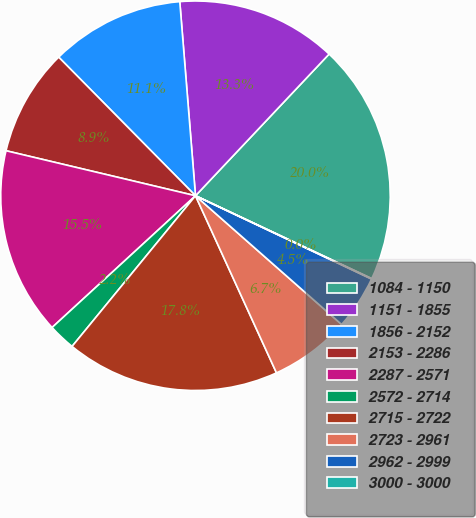<chart> <loc_0><loc_0><loc_500><loc_500><pie_chart><fcel>1084 - 1150<fcel>1151 - 1855<fcel>1856 - 2152<fcel>2153 - 2286<fcel>2287 - 2571<fcel>2572 - 2714<fcel>2715 - 2722<fcel>2723 - 2961<fcel>2962 - 2999<fcel>3000 - 3000<nl><fcel>19.96%<fcel>13.32%<fcel>11.11%<fcel>8.89%<fcel>15.54%<fcel>2.25%<fcel>17.75%<fcel>6.68%<fcel>4.46%<fcel>0.04%<nl></chart> 